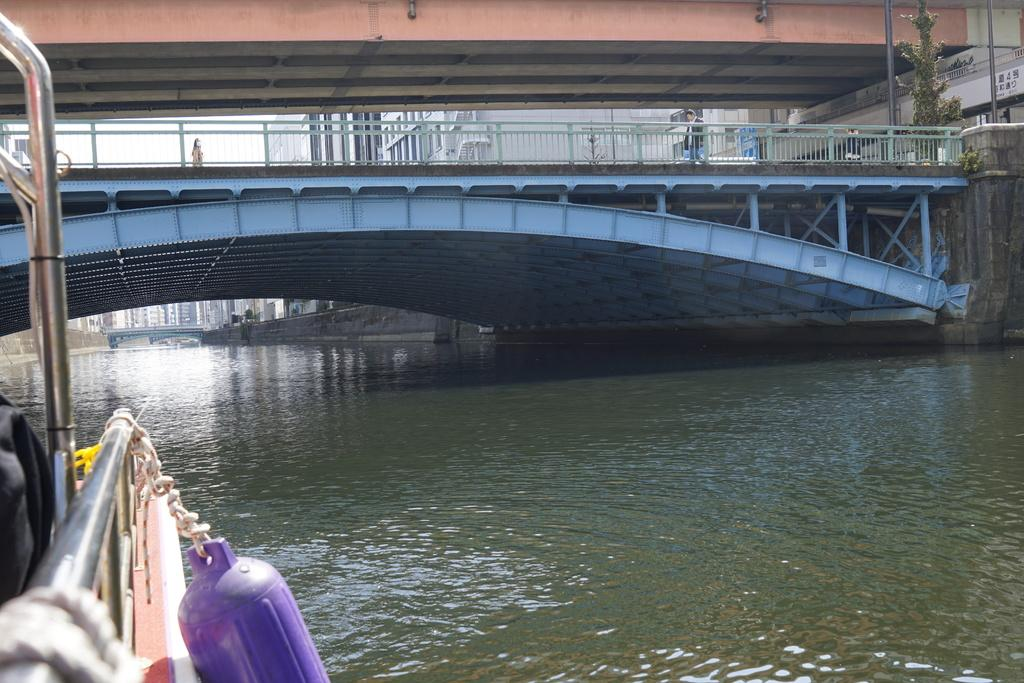What is located on the left side of the image? There is a boat on the left side of the image. What feature does the boat have? The boat has a cylinder. Where is the boat situated? The boat is on the water. What can be seen in the background of the image? There are bridges, buildings, and poles in the background of the image. What is visible in the sky? There are clouds in the sky. How many men are visible in the image, and what are they doing? There are no men present in the image. What type of print can be seen on the boat's surface? There is no print visible on the boat's surface in the image. 